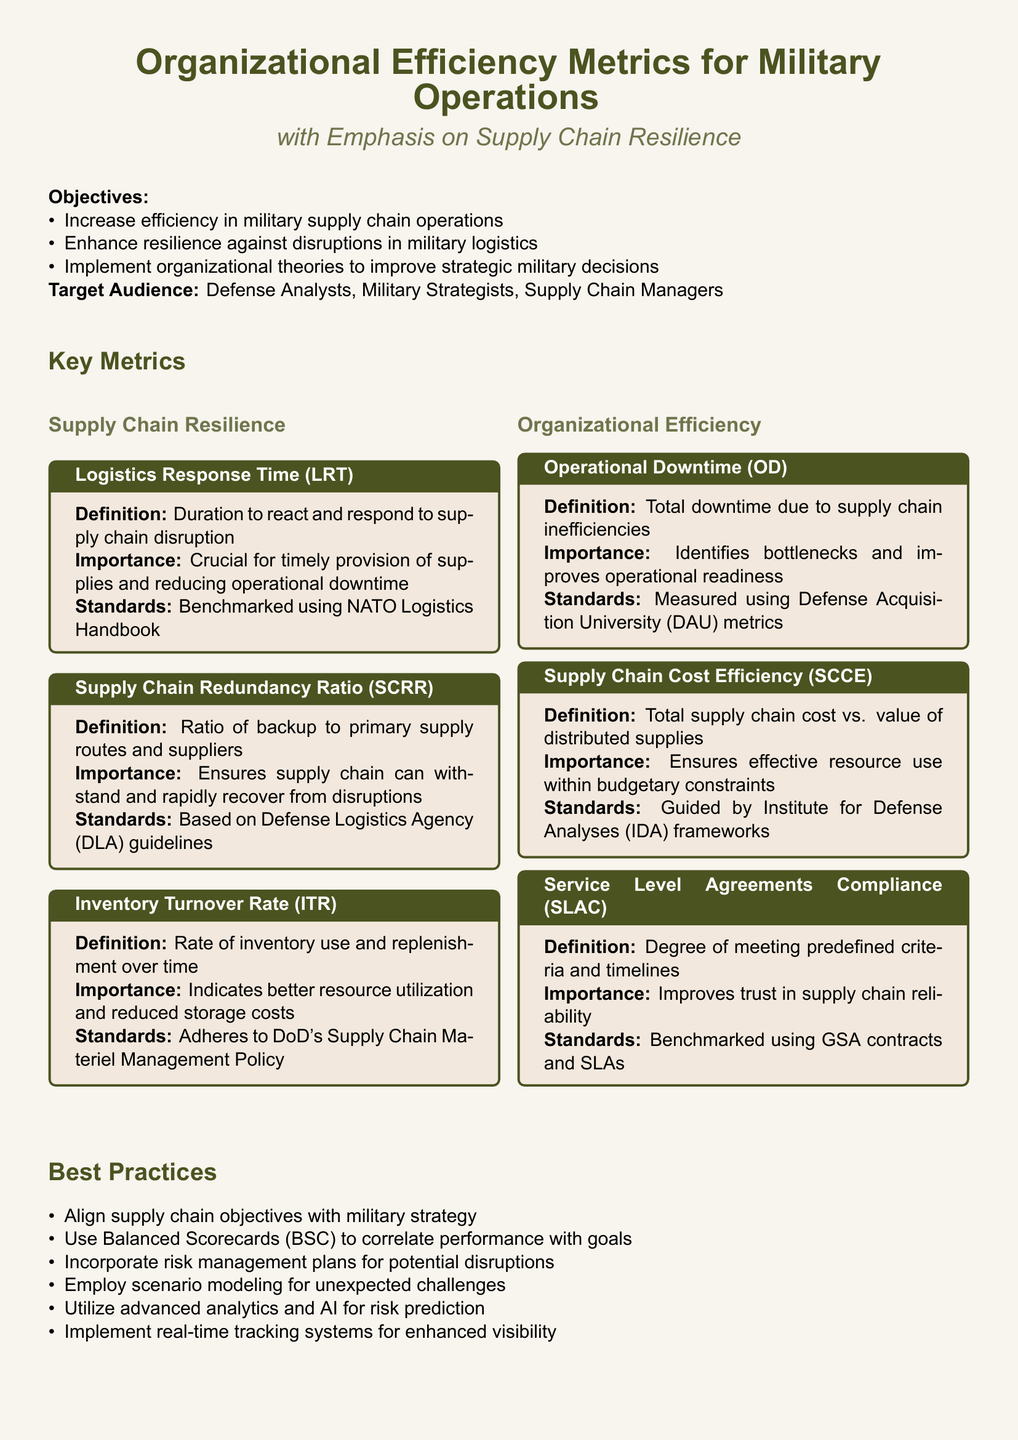What is the emphasis of the document? The emphasis of the document is on supply chain resilience within military operations.
Answer: Supply Chain Resilience Who is the target audience for this document? The target audience includes defense analysts, military strategists, and supply chain managers.
Answer: Defense Analysts, Military Strategists, Supply Chain Managers What does Logistics Response Time measure? Logistics Response Time measures the duration to react and respond to supply chain disruption.
Answer: Duration to react and respond to supply chain disruption What is the importance of the Supply Chain Redundancy Ratio? The importance of the Supply Chain Redundancy Ratio is to ensure that the supply chain can withstand and recover from disruptions.
Answer: Ensures supply chain can withstand and rapidly recover from disruptions What practice is recommended for incorporating risk management? The practice recommended for incorporating risk management is to implement risk management plans for potential disruptions.
Answer: Implement risk management plans What case study shows optimization of inventory turnover? The case study showing optimization of inventory turnover is related to the US Army's improvements in stocking procedures.
Answer: US Army's Inventory Turnover Optimization What metric is guided by the Institute for Defense Analyses frameworks? The metric guided by the Institute for Defense Analyses frameworks is Supply Chain Cost Efficiency.
Answer: Supply Chain Cost Efficiency What is the benchmark for Service Level Agreements Compliance? The benchmark for Service Level Agreements Compliance is based on GSA contracts and SLAs.
Answer: GSA contracts and SLAs 